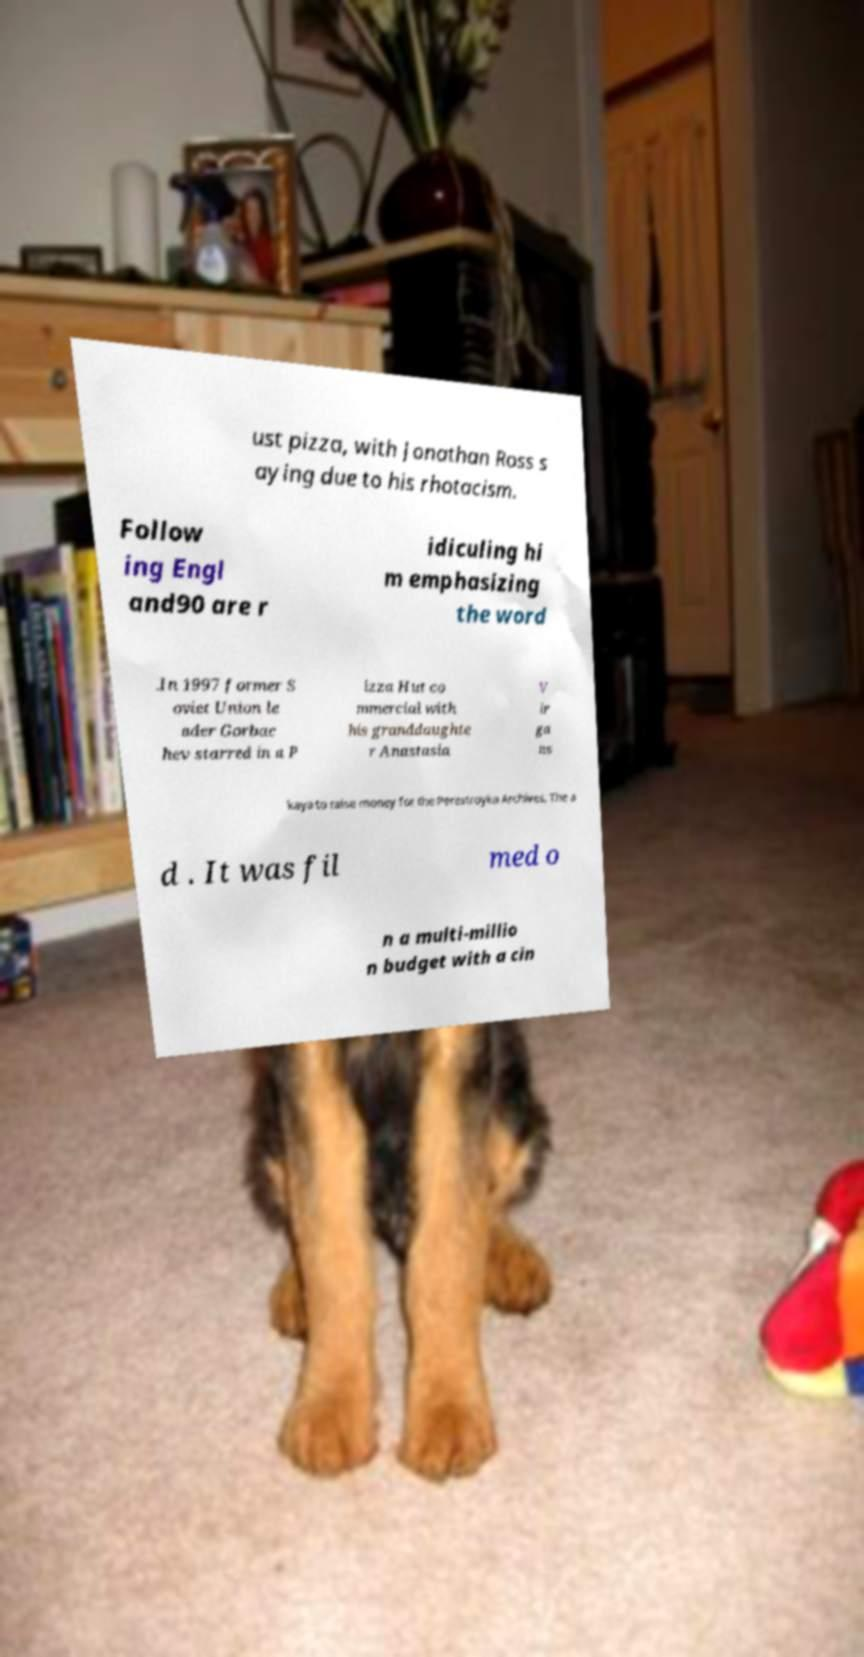Please identify and transcribe the text found in this image. ust pizza, with Jonathan Ross s aying due to his rhotacism. Follow ing Engl and90 are r idiculing hi m emphasizing the word .In 1997 former S oviet Union le ader Gorbac hev starred in a P izza Hut co mmercial with his granddaughte r Anastasia V ir ga ns kaya to raise money for the Perestroyka Archives. The a d . It was fil med o n a multi-millio n budget with a cin 